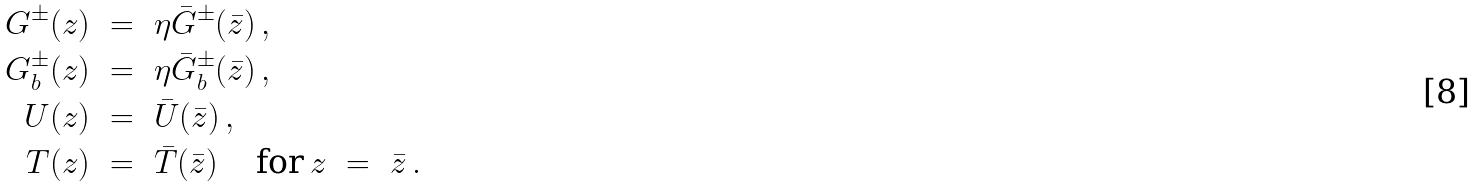<formula> <loc_0><loc_0><loc_500><loc_500>G ^ { \pm } ( z ) \ & = \ \eta \bar { G } ^ { \pm } ( \bar { z } ) \, , \\ G _ { b } ^ { \pm } ( z ) \ & = \ \eta \bar { G } _ { b } ^ { \pm } ( \bar { z } ) \, , \\ U ( z ) \ & = \ \bar { U } ( \bar { z } ) \, , \\ T ( z ) \ & = \ \bar { T } ( \bar { z } ) \, \quad \text {for} \, z \ = \ \bar { z } \, . \\</formula> 